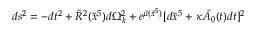<formula> <loc_0><loc_0><loc_500><loc_500>d s ^ { 2 } = - d t ^ { 2 } + \tilde { R } ^ { 2 } ( \tilde { x } ^ { 5 } ) d \Omega _ { k } ^ { 2 } + e ^ { \tilde { \mu } ( \tilde { x } ^ { 5 } ) } [ d \tilde { x } ^ { 5 } + \kappa \tilde { A _ { 0 } } ( t ) d t ] ^ { 2 }</formula> 